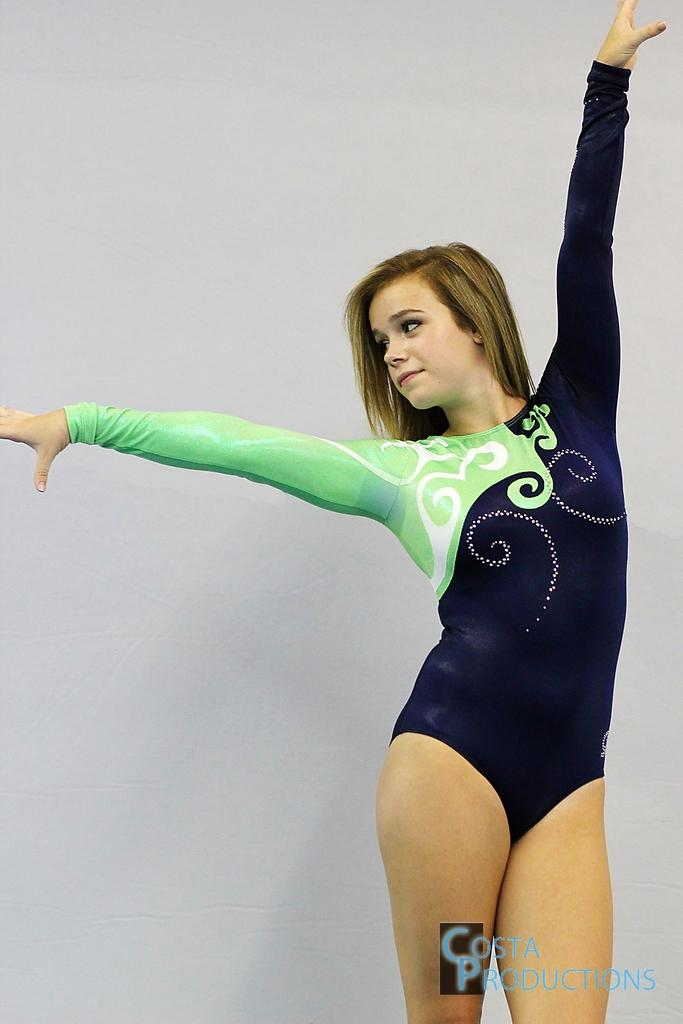What is the position of the woman in the image? The woman is standing on the right side of the image. What can be seen in the background of the image? There is a white color wall in the background. Where is the logo located in the image? The logo is at the bottom of the image. What type of pencil is being used to draw on the wall in the image? There is no pencil or drawing on the wall in the image. 